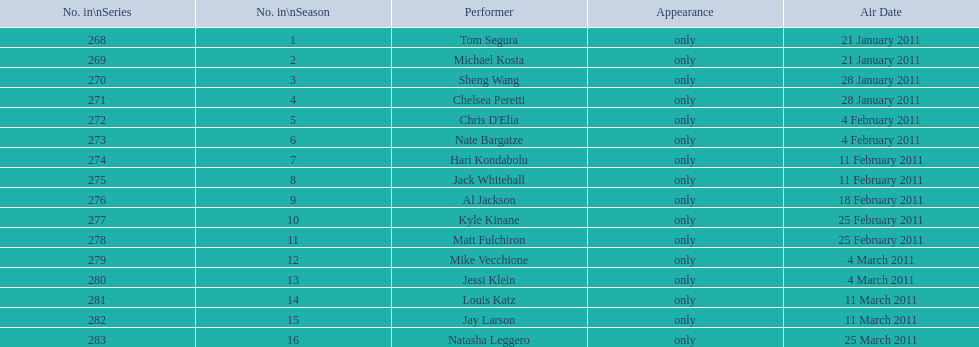In february, what was the overall number of air dates? 7. I'm looking to parse the entire table for insights. Could you assist me with that? {'header': ['No. in\\nSeries', 'No. in\\nSeason', 'Performer', 'Appearance', 'Air Date'], 'rows': [['268', '1', 'Tom Segura', 'only', '21 January 2011'], ['269', '2', 'Michael Kosta', 'only', '21 January 2011'], ['270', '3', 'Sheng Wang', 'only', '28 January 2011'], ['271', '4', 'Chelsea Peretti', 'only', '28 January 2011'], ['272', '5', "Chris D'Elia", 'only', '4 February 2011'], ['273', '6', 'Nate Bargatze', 'only', '4 February 2011'], ['274', '7', 'Hari Kondabolu', 'only', '11 February 2011'], ['275', '8', 'Jack Whitehall', 'only', '11 February 2011'], ['276', '9', 'Al Jackson', 'only', '18 February 2011'], ['277', '10', 'Kyle Kinane', 'only', '25 February 2011'], ['278', '11', 'Matt Fulchiron', 'only', '25 February 2011'], ['279', '12', 'Mike Vecchione', 'only', '4 March 2011'], ['280', '13', 'Jessi Klein', 'only', '4 March 2011'], ['281', '14', 'Louis Katz', 'only', '11 March 2011'], ['282', '15', 'Jay Larson', 'only', '11 March 2011'], ['283', '16', 'Natasha Leggero', 'only', '25 March 2011']]} 